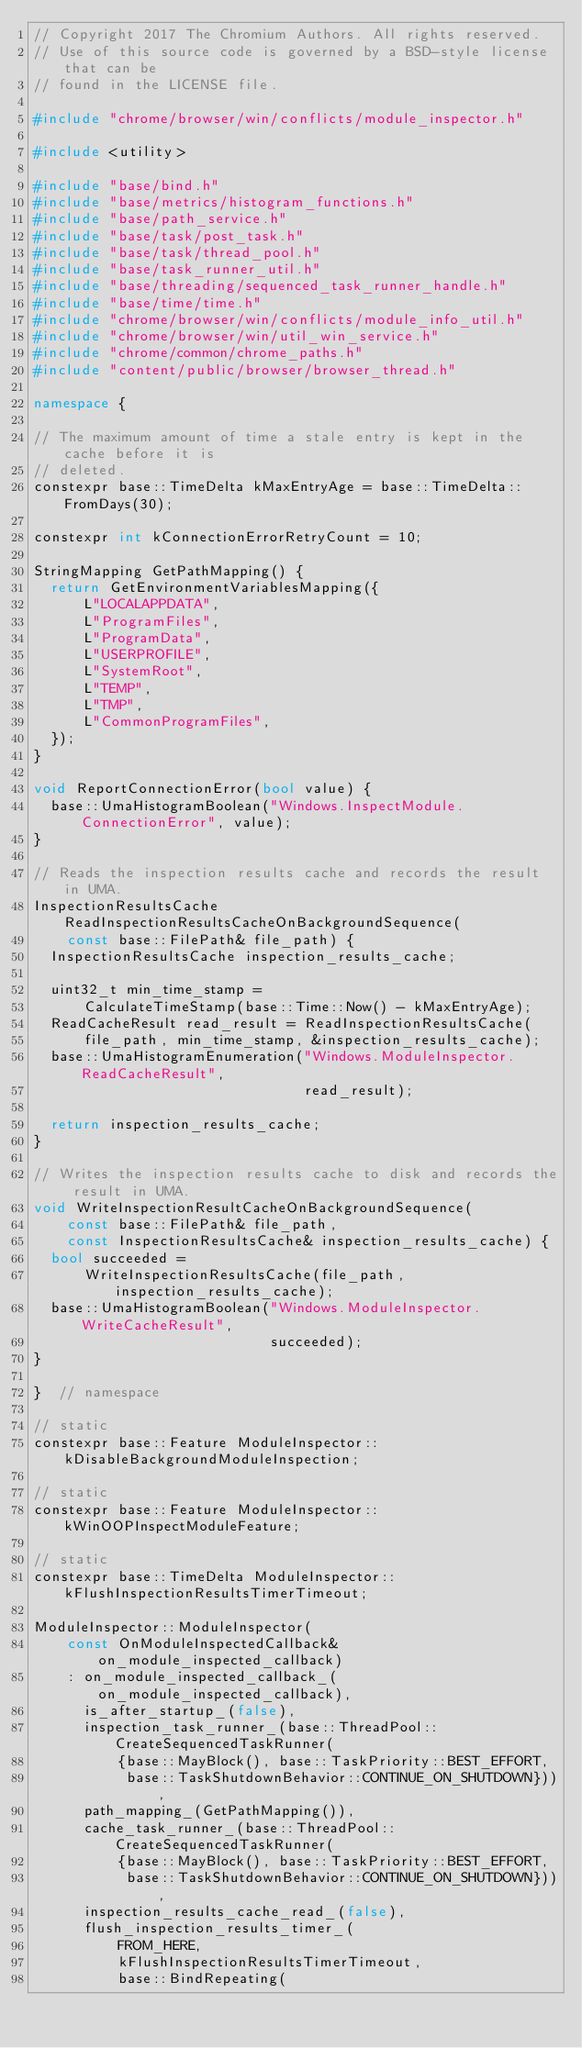Convert code to text. <code><loc_0><loc_0><loc_500><loc_500><_C++_>// Copyright 2017 The Chromium Authors. All rights reserved.
// Use of this source code is governed by a BSD-style license that can be
// found in the LICENSE file.

#include "chrome/browser/win/conflicts/module_inspector.h"

#include <utility>

#include "base/bind.h"
#include "base/metrics/histogram_functions.h"
#include "base/path_service.h"
#include "base/task/post_task.h"
#include "base/task/thread_pool.h"
#include "base/task_runner_util.h"
#include "base/threading/sequenced_task_runner_handle.h"
#include "base/time/time.h"
#include "chrome/browser/win/conflicts/module_info_util.h"
#include "chrome/browser/win/util_win_service.h"
#include "chrome/common/chrome_paths.h"
#include "content/public/browser/browser_thread.h"

namespace {

// The maximum amount of time a stale entry is kept in the cache before it is
// deleted.
constexpr base::TimeDelta kMaxEntryAge = base::TimeDelta::FromDays(30);

constexpr int kConnectionErrorRetryCount = 10;

StringMapping GetPathMapping() {
  return GetEnvironmentVariablesMapping({
      L"LOCALAPPDATA",
      L"ProgramFiles",
      L"ProgramData",
      L"USERPROFILE",
      L"SystemRoot",
      L"TEMP",
      L"TMP",
      L"CommonProgramFiles",
  });
}

void ReportConnectionError(bool value) {
  base::UmaHistogramBoolean("Windows.InspectModule.ConnectionError", value);
}

// Reads the inspection results cache and records the result in UMA.
InspectionResultsCache ReadInspectionResultsCacheOnBackgroundSequence(
    const base::FilePath& file_path) {
  InspectionResultsCache inspection_results_cache;

  uint32_t min_time_stamp =
      CalculateTimeStamp(base::Time::Now() - kMaxEntryAge);
  ReadCacheResult read_result = ReadInspectionResultsCache(
      file_path, min_time_stamp, &inspection_results_cache);
  base::UmaHistogramEnumeration("Windows.ModuleInspector.ReadCacheResult",
                                read_result);

  return inspection_results_cache;
}

// Writes the inspection results cache to disk and records the result in UMA.
void WriteInspectionResultCacheOnBackgroundSequence(
    const base::FilePath& file_path,
    const InspectionResultsCache& inspection_results_cache) {
  bool succeeded =
      WriteInspectionResultsCache(file_path, inspection_results_cache);
  base::UmaHistogramBoolean("Windows.ModuleInspector.WriteCacheResult",
                            succeeded);
}

}  // namespace

// static
constexpr base::Feature ModuleInspector::kDisableBackgroundModuleInspection;

// static
constexpr base::Feature ModuleInspector::kWinOOPInspectModuleFeature;

// static
constexpr base::TimeDelta ModuleInspector::kFlushInspectionResultsTimerTimeout;

ModuleInspector::ModuleInspector(
    const OnModuleInspectedCallback& on_module_inspected_callback)
    : on_module_inspected_callback_(on_module_inspected_callback),
      is_after_startup_(false),
      inspection_task_runner_(base::ThreadPool::CreateSequencedTaskRunner(
          {base::MayBlock(), base::TaskPriority::BEST_EFFORT,
           base::TaskShutdownBehavior::CONTINUE_ON_SHUTDOWN})),
      path_mapping_(GetPathMapping()),
      cache_task_runner_(base::ThreadPool::CreateSequencedTaskRunner(
          {base::MayBlock(), base::TaskPriority::BEST_EFFORT,
           base::TaskShutdownBehavior::CONTINUE_ON_SHUTDOWN})),
      inspection_results_cache_read_(false),
      flush_inspection_results_timer_(
          FROM_HERE,
          kFlushInspectionResultsTimerTimeout,
          base::BindRepeating(</code> 